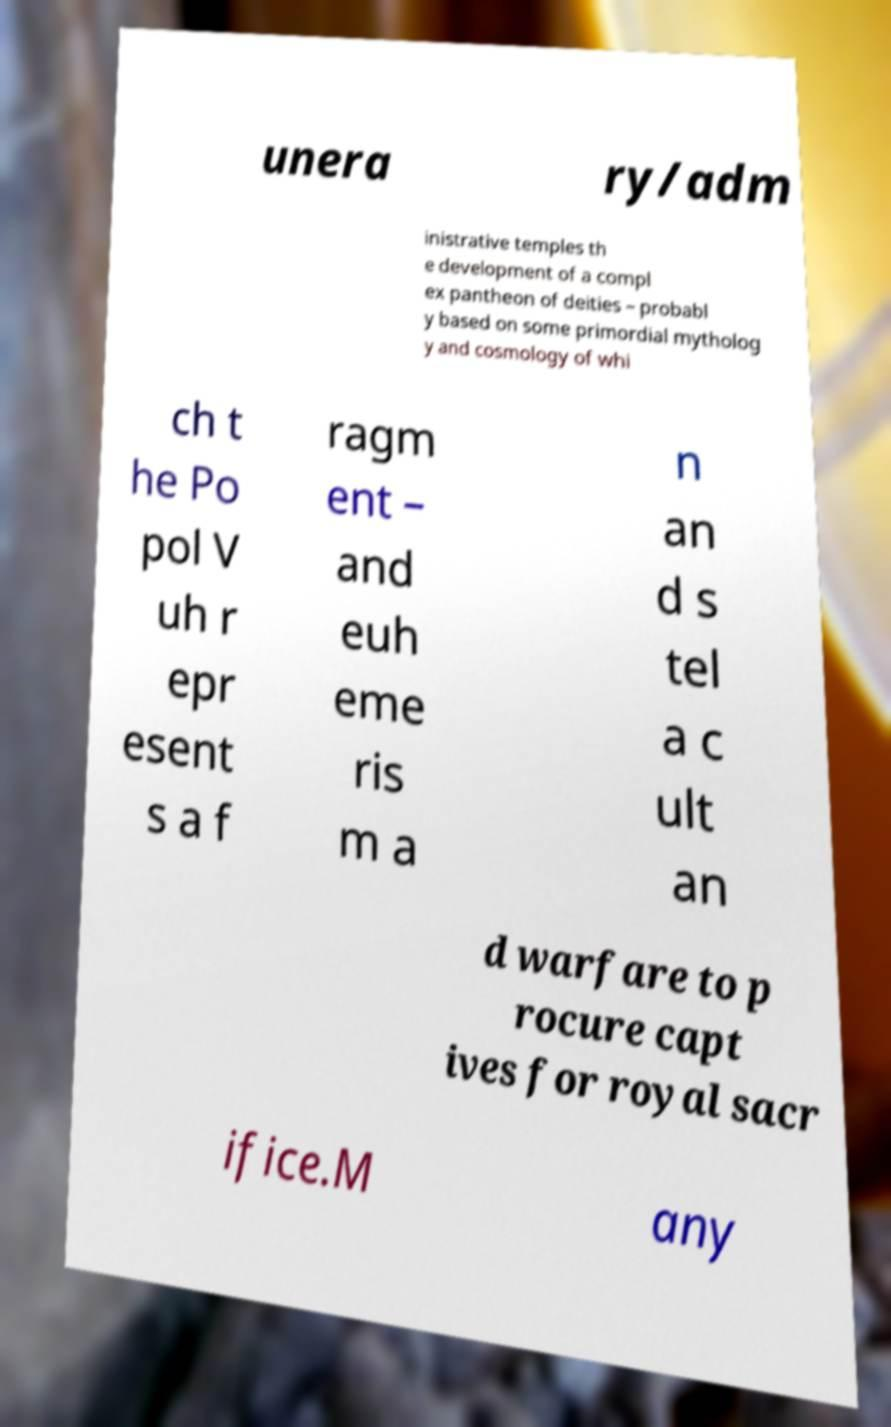Please read and relay the text visible in this image. What does it say? unera ry/adm inistrative temples th e development of a compl ex pantheon of deities – probabl y based on some primordial mytholog y and cosmology of whi ch t he Po pol V uh r epr esent s a f ragm ent – and euh eme ris m a n an d s tel a c ult an d warfare to p rocure capt ives for royal sacr ifice.M any 